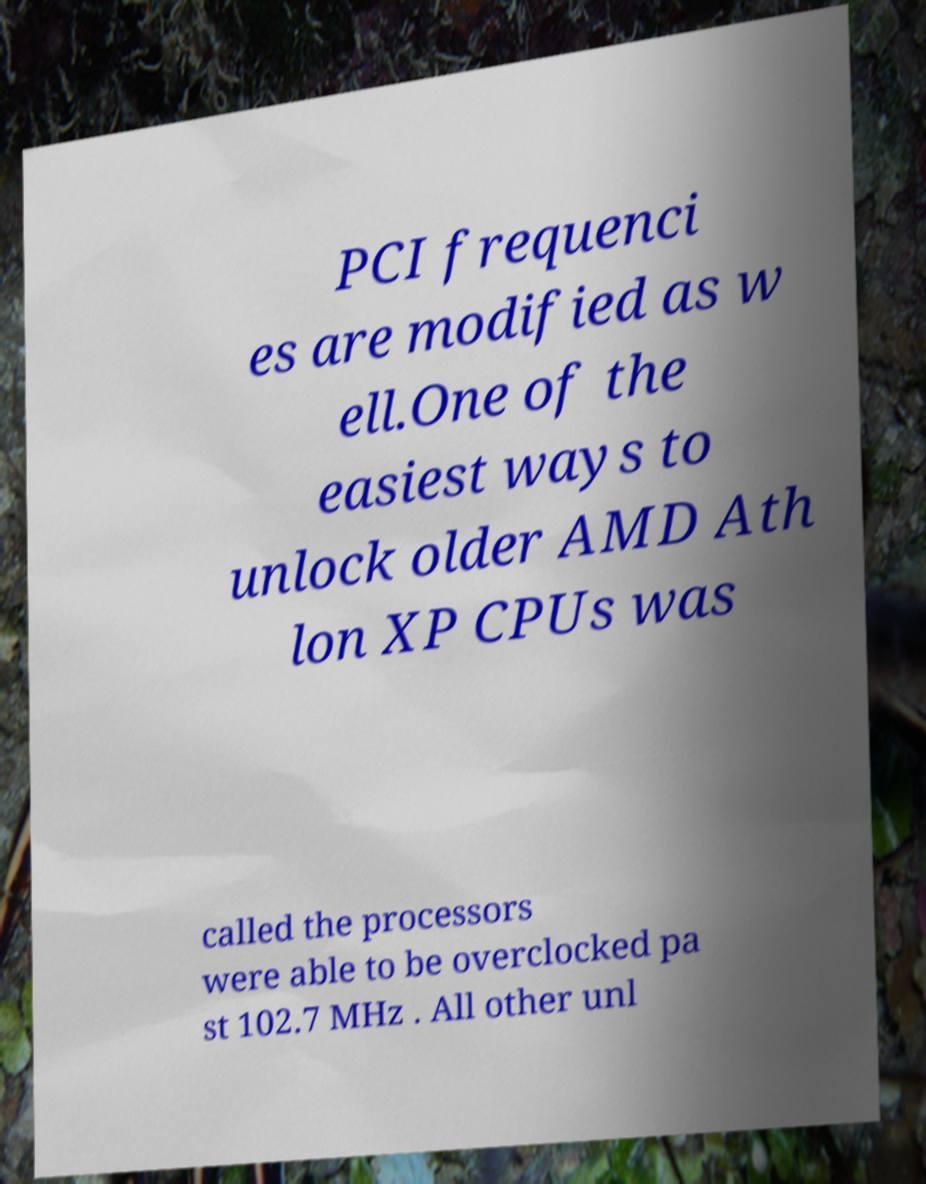I need the written content from this picture converted into text. Can you do that? PCI frequenci es are modified as w ell.One of the easiest ways to unlock older AMD Ath lon XP CPUs was called the processors were able to be overclocked pa st 102.7 MHz . All other unl 